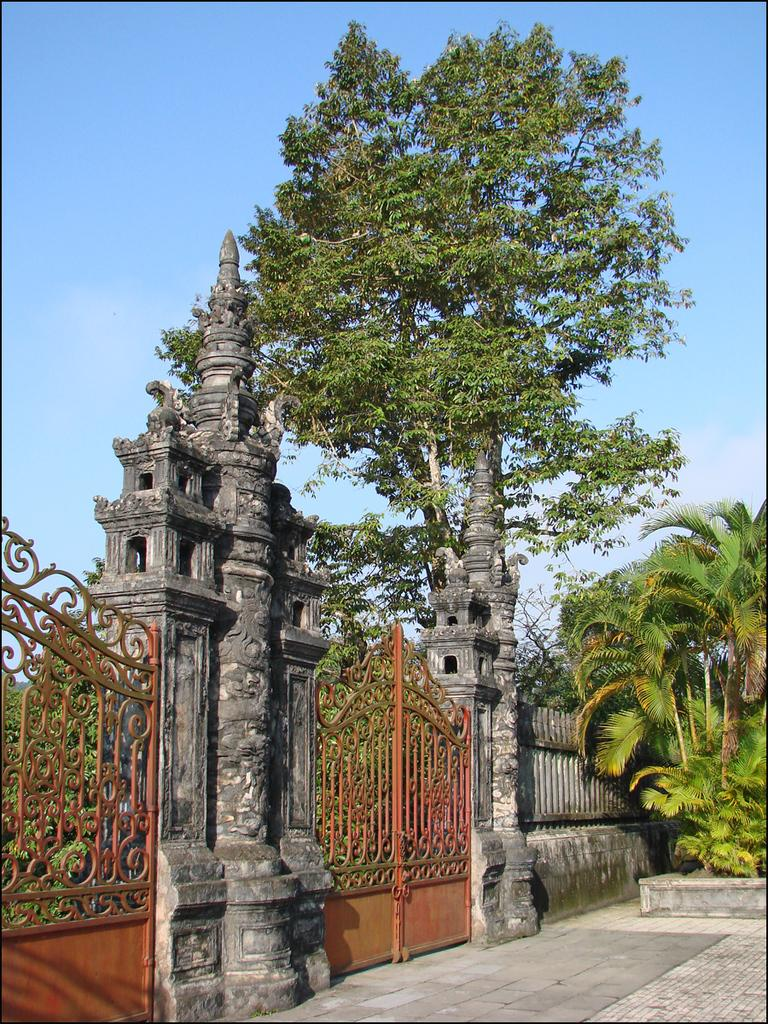What structures can be seen in the image? There are gates and pillars in the image. What type of vegetation is present in the image? There are trees in the image. What type of barrier can be seen in the image? There is a fence in the image. What can be seen in the background of the image? The sky is visible in the background of the image. How many pins are used to hold the gates in the image? There is no mention of pins being used to hold the gates in the image. What type of animal can be seen interacting with the trees in the image? There is no animal, such as a giraffe, present in the image. 